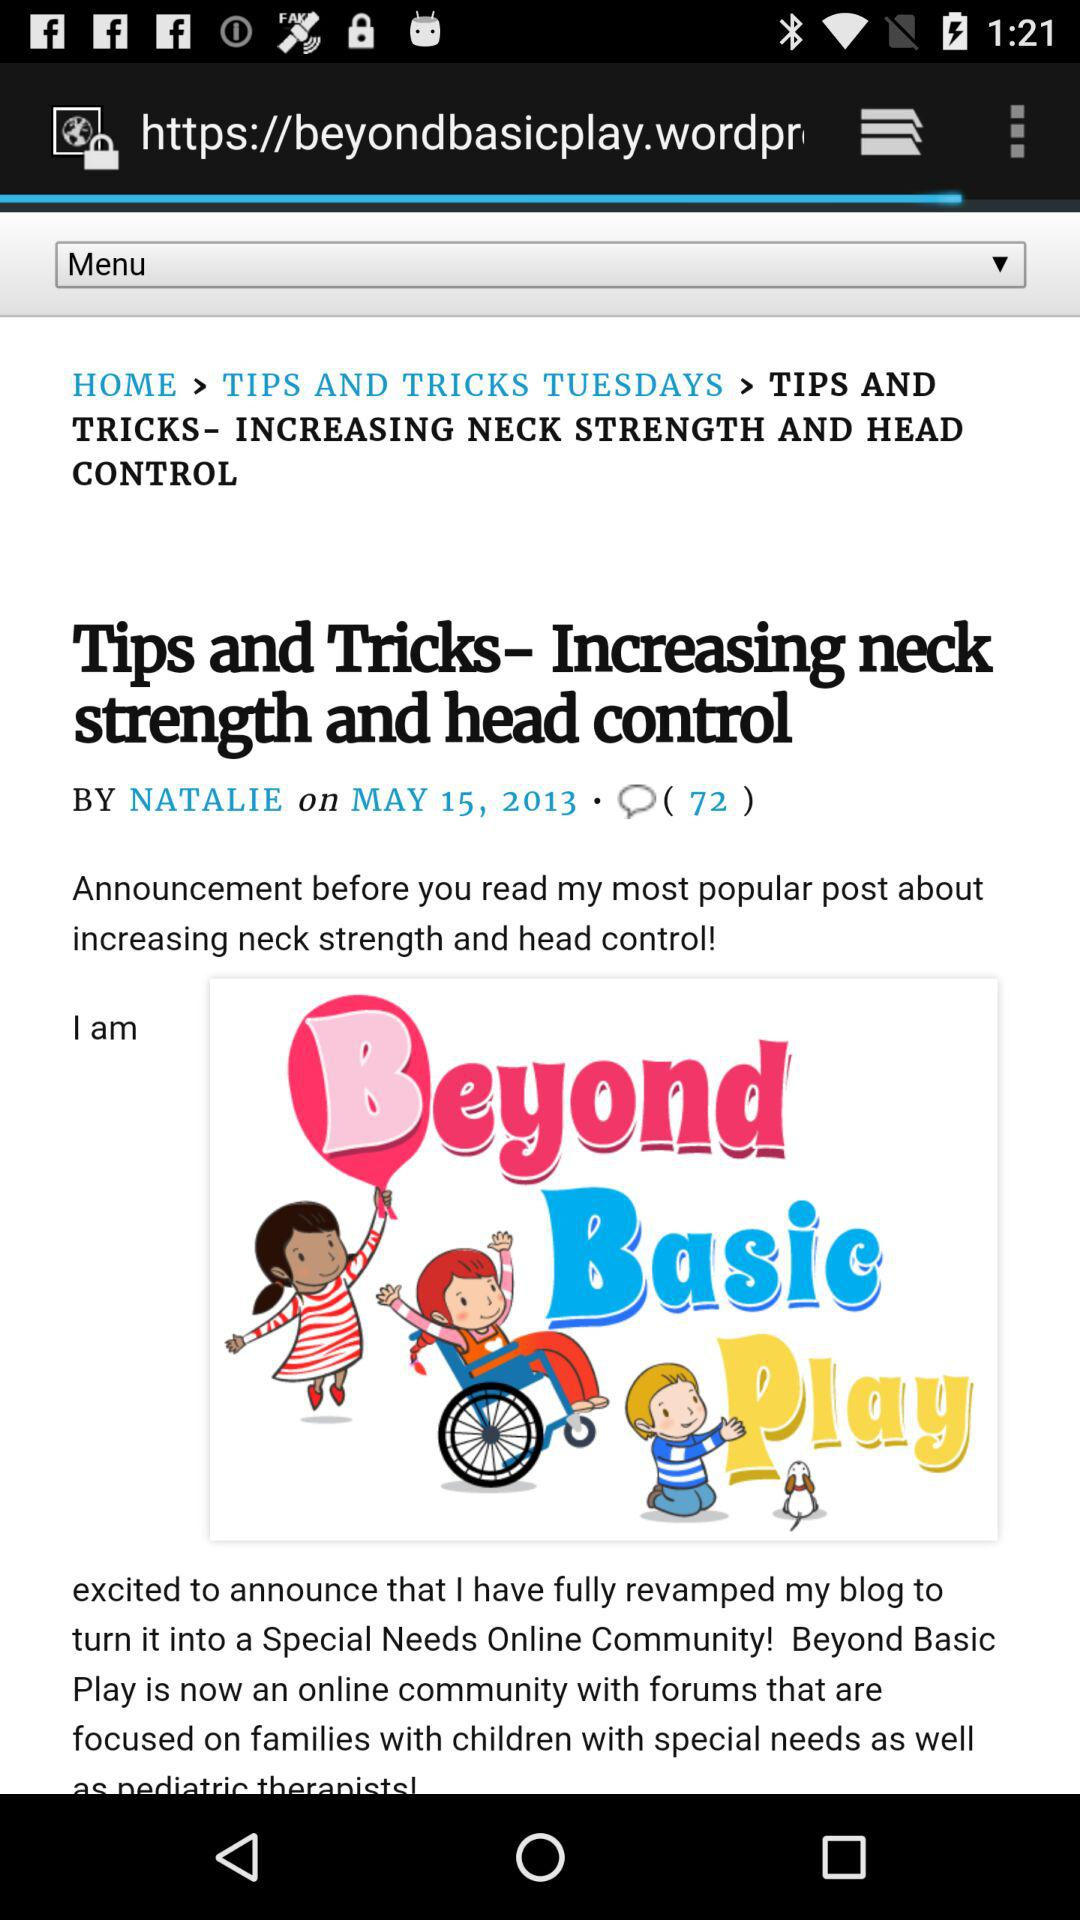What is the publication date? The publication date is May 15, 2013. 